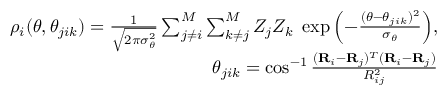Convert formula to latex. <formula><loc_0><loc_0><loc_500><loc_500>\begin{array} { r } { \rho _ { i } ( \theta , \theta _ { j i k } ) = \frac { 1 } { \sqrt { 2 \pi \sigma _ { \theta } ^ { 2 } } } \sum _ { j \neq i } ^ { M } \sum _ { k \neq j } ^ { M } Z _ { j } Z _ { k } \exp { \left ( - \frac { ( \theta - \theta _ { j i k } ) ^ { 2 } } { \sigma _ { \theta } } \right ) } , } \\ { \theta _ { j i k } = \cos ^ { - 1 } \frac { ( R _ { i } - R _ { j } ) ^ { T } ( R _ { i } - R _ { j } ) } { R _ { i j } ^ { 2 } } } \end{array}</formula> 